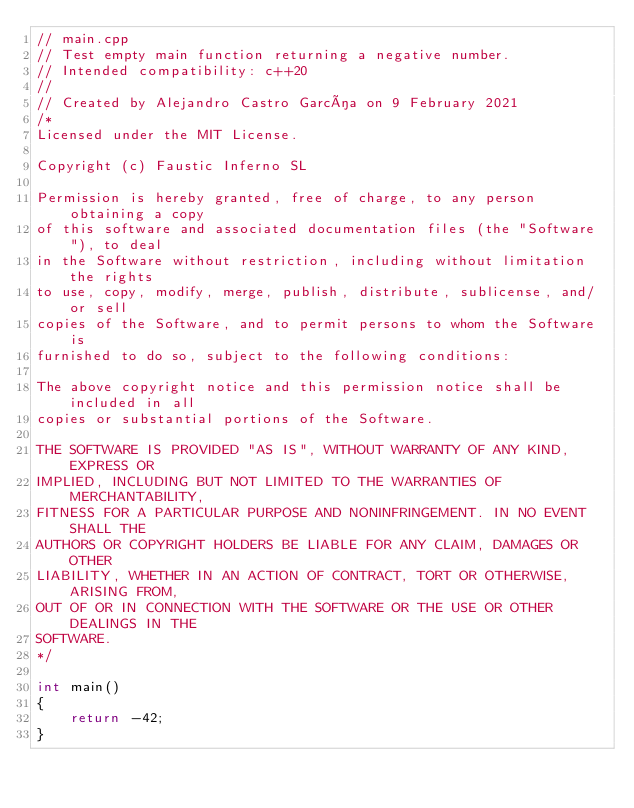Convert code to text. <code><loc_0><loc_0><loc_500><loc_500><_C++_>// main.cpp
// Test empty main function returning a negative number.
// Intended compatibility: c++20
//
// Created by Alejandro Castro García on 9 February 2021
/*
Licensed under the MIT License.
 
Copyright (c) Faustic Inferno SL
 
Permission is hereby granted, free of charge, to any person obtaining a copy
of this software and associated documentation files (the "Software"), to deal
in the Software without restriction, including without limitation the rights
to use, copy, modify, merge, publish, distribute, sublicense, and/or sell
copies of the Software, and to permit persons to whom the Software is
furnished to do so, subject to the following conditions:

The above copyright notice and this permission notice shall be included in all
copies or substantial portions of the Software.

THE SOFTWARE IS PROVIDED "AS IS", WITHOUT WARRANTY OF ANY KIND, EXPRESS OR
IMPLIED, INCLUDING BUT NOT LIMITED TO THE WARRANTIES OF MERCHANTABILITY,
FITNESS FOR A PARTICULAR PURPOSE AND NONINFRINGEMENT. IN NO EVENT SHALL THE
AUTHORS OR COPYRIGHT HOLDERS BE LIABLE FOR ANY CLAIM, DAMAGES OR OTHER
LIABILITY, WHETHER IN AN ACTION OF CONTRACT, TORT OR OTHERWISE, ARISING FROM,
OUT OF OR IN CONNECTION WITH THE SOFTWARE OR THE USE OR OTHER DEALINGS IN THE
SOFTWARE.
*/

int main()
{
    return -42;
}
</code> 